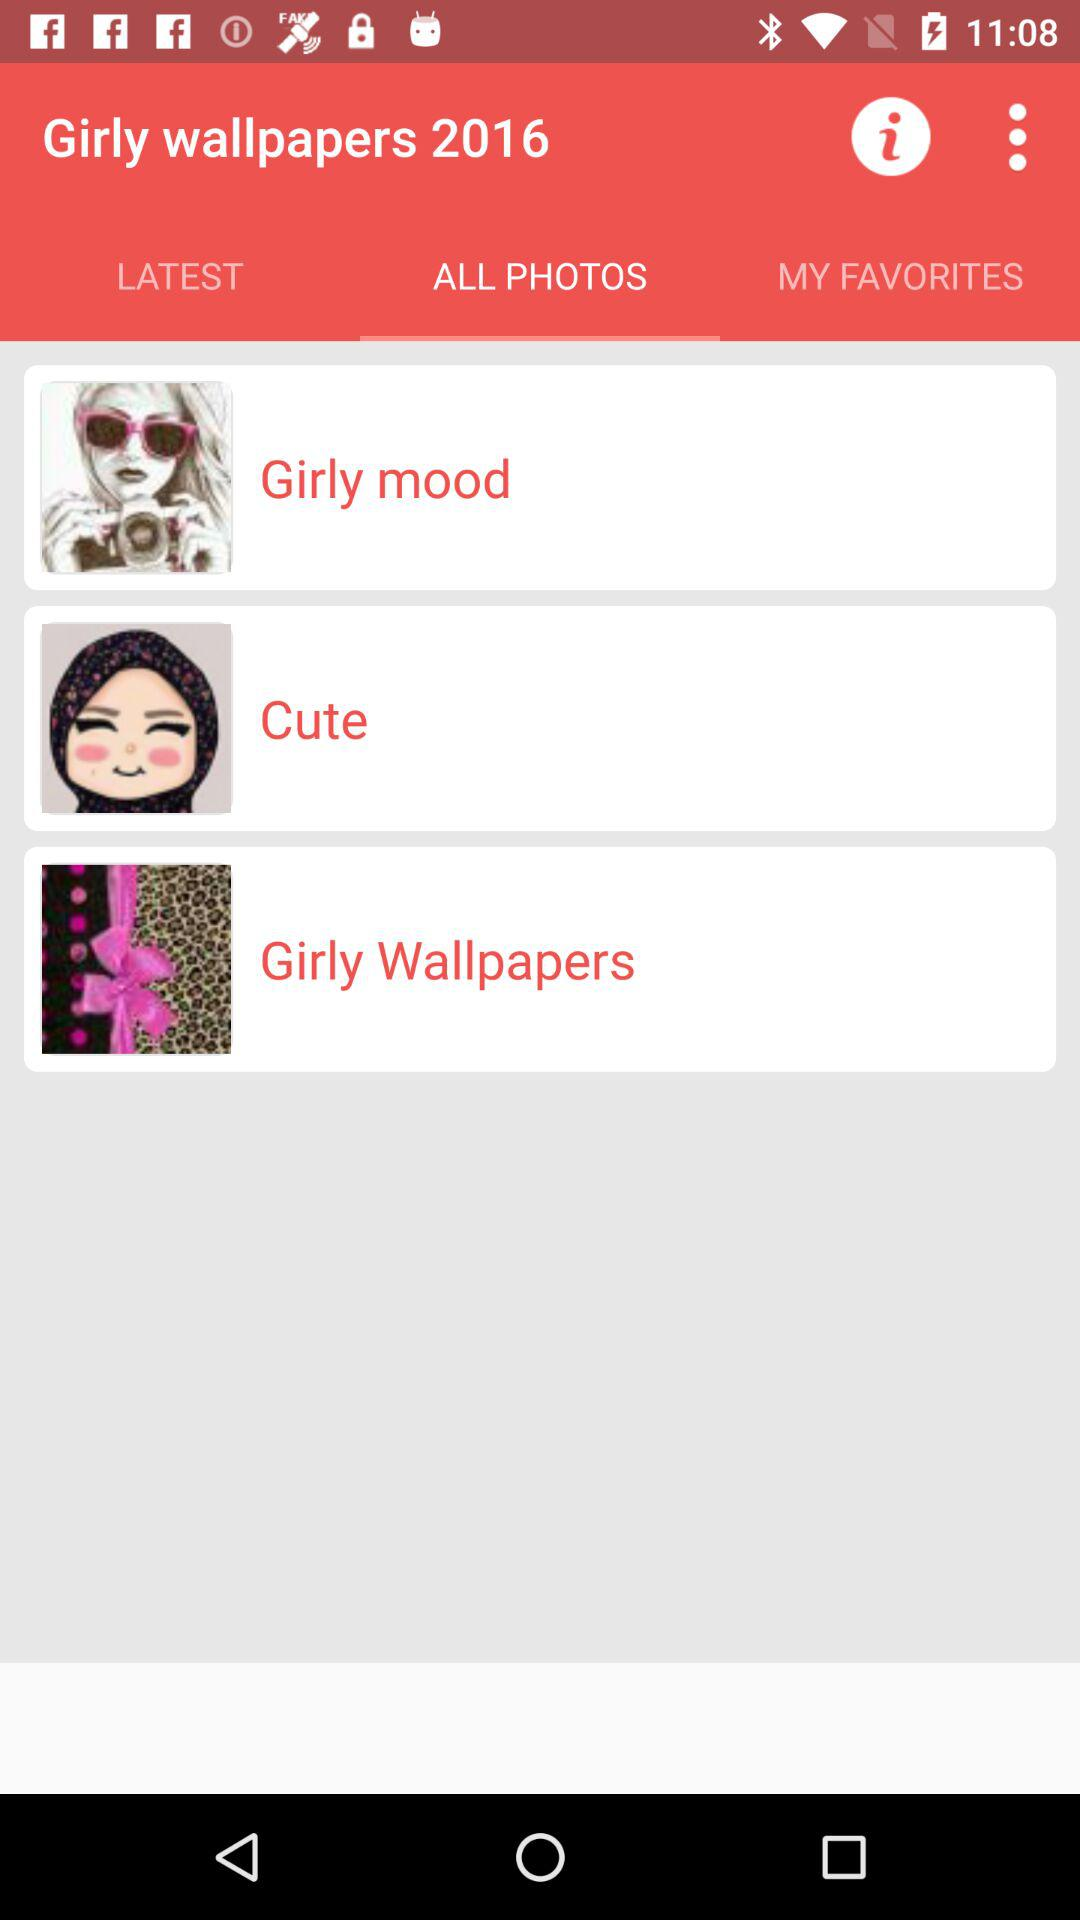What are the categories in "ALL PHOTOS"? The categories are "Girly mood", "Cute", and "Girly Wallpapers". 